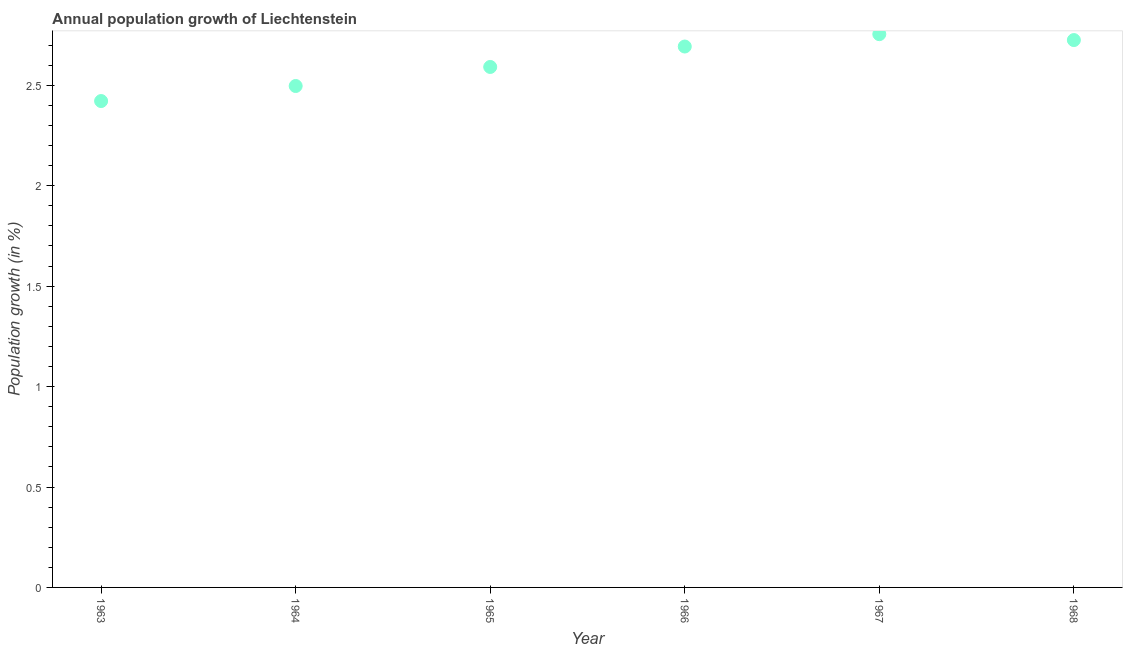What is the population growth in 1964?
Provide a succinct answer. 2.5. Across all years, what is the maximum population growth?
Your answer should be compact. 2.75. Across all years, what is the minimum population growth?
Provide a succinct answer. 2.42. In which year was the population growth maximum?
Offer a terse response. 1967. What is the sum of the population growth?
Give a very brief answer. 15.68. What is the difference between the population growth in 1964 and 1965?
Provide a short and direct response. -0.09. What is the average population growth per year?
Offer a very short reply. 2.61. What is the median population growth?
Give a very brief answer. 2.64. In how many years, is the population growth greater than 0.4 %?
Offer a very short reply. 6. Do a majority of the years between 1963 and 1967 (inclusive) have population growth greater than 1.2 %?
Keep it short and to the point. Yes. What is the ratio of the population growth in 1963 to that in 1964?
Your answer should be very brief. 0.97. Is the population growth in 1965 less than that in 1966?
Make the answer very short. Yes. Is the difference between the population growth in 1965 and 1966 greater than the difference between any two years?
Provide a short and direct response. No. What is the difference between the highest and the second highest population growth?
Ensure brevity in your answer.  0.03. What is the difference between the highest and the lowest population growth?
Give a very brief answer. 0.33. In how many years, is the population growth greater than the average population growth taken over all years?
Ensure brevity in your answer.  3. Does the population growth monotonically increase over the years?
Your answer should be very brief. No. How many dotlines are there?
Keep it short and to the point. 1. How many years are there in the graph?
Your answer should be compact. 6. What is the difference between two consecutive major ticks on the Y-axis?
Provide a short and direct response. 0.5. Are the values on the major ticks of Y-axis written in scientific E-notation?
Give a very brief answer. No. What is the title of the graph?
Your answer should be compact. Annual population growth of Liechtenstein. What is the label or title of the X-axis?
Offer a terse response. Year. What is the label or title of the Y-axis?
Provide a succinct answer. Population growth (in %). What is the Population growth (in %) in 1963?
Offer a terse response. 2.42. What is the Population growth (in %) in 1964?
Offer a very short reply. 2.5. What is the Population growth (in %) in 1965?
Your response must be concise. 2.59. What is the Population growth (in %) in 1966?
Ensure brevity in your answer.  2.69. What is the Population growth (in %) in 1967?
Offer a terse response. 2.75. What is the Population growth (in %) in 1968?
Offer a terse response. 2.73. What is the difference between the Population growth (in %) in 1963 and 1964?
Your answer should be very brief. -0.07. What is the difference between the Population growth (in %) in 1963 and 1965?
Provide a short and direct response. -0.17. What is the difference between the Population growth (in %) in 1963 and 1966?
Provide a succinct answer. -0.27. What is the difference between the Population growth (in %) in 1963 and 1967?
Your answer should be compact. -0.33. What is the difference between the Population growth (in %) in 1963 and 1968?
Offer a terse response. -0.3. What is the difference between the Population growth (in %) in 1964 and 1965?
Give a very brief answer. -0.09. What is the difference between the Population growth (in %) in 1964 and 1966?
Make the answer very short. -0.2. What is the difference between the Population growth (in %) in 1964 and 1967?
Give a very brief answer. -0.26. What is the difference between the Population growth (in %) in 1964 and 1968?
Give a very brief answer. -0.23. What is the difference between the Population growth (in %) in 1965 and 1966?
Ensure brevity in your answer.  -0.1. What is the difference between the Population growth (in %) in 1965 and 1967?
Keep it short and to the point. -0.16. What is the difference between the Population growth (in %) in 1965 and 1968?
Provide a short and direct response. -0.13. What is the difference between the Population growth (in %) in 1966 and 1967?
Offer a very short reply. -0.06. What is the difference between the Population growth (in %) in 1966 and 1968?
Provide a succinct answer. -0.03. What is the difference between the Population growth (in %) in 1967 and 1968?
Your answer should be very brief. 0.03. What is the ratio of the Population growth (in %) in 1963 to that in 1964?
Your answer should be very brief. 0.97. What is the ratio of the Population growth (in %) in 1963 to that in 1965?
Keep it short and to the point. 0.93. What is the ratio of the Population growth (in %) in 1963 to that in 1966?
Your response must be concise. 0.9. What is the ratio of the Population growth (in %) in 1963 to that in 1967?
Make the answer very short. 0.88. What is the ratio of the Population growth (in %) in 1963 to that in 1968?
Offer a terse response. 0.89. What is the ratio of the Population growth (in %) in 1964 to that in 1966?
Make the answer very short. 0.93. What is the ratio of the Population growth (in %) in 1964 to that in 1967?
Your response must be concise. 0.91. What is the ratio of the Population growth (in %) in 1964 to that in 1968?
Provide a short and direct response. 0.92. What is the ratio of the Population growth (in %) in 1965 to that in 1966?
Offer a very short reply. 0.96. What is the ratio of the Population growth (in %) in 1965 to that in 1967?
Provide a short and direct response. 0.94. What is the ratio of the Population growth (in %) in 1965 to that in 1968?
Give a very brief answer. 0.95. What is the ratio of the Population growth (in %) in 1967 to that in 1968?
Your response must be concise. 1.01. 